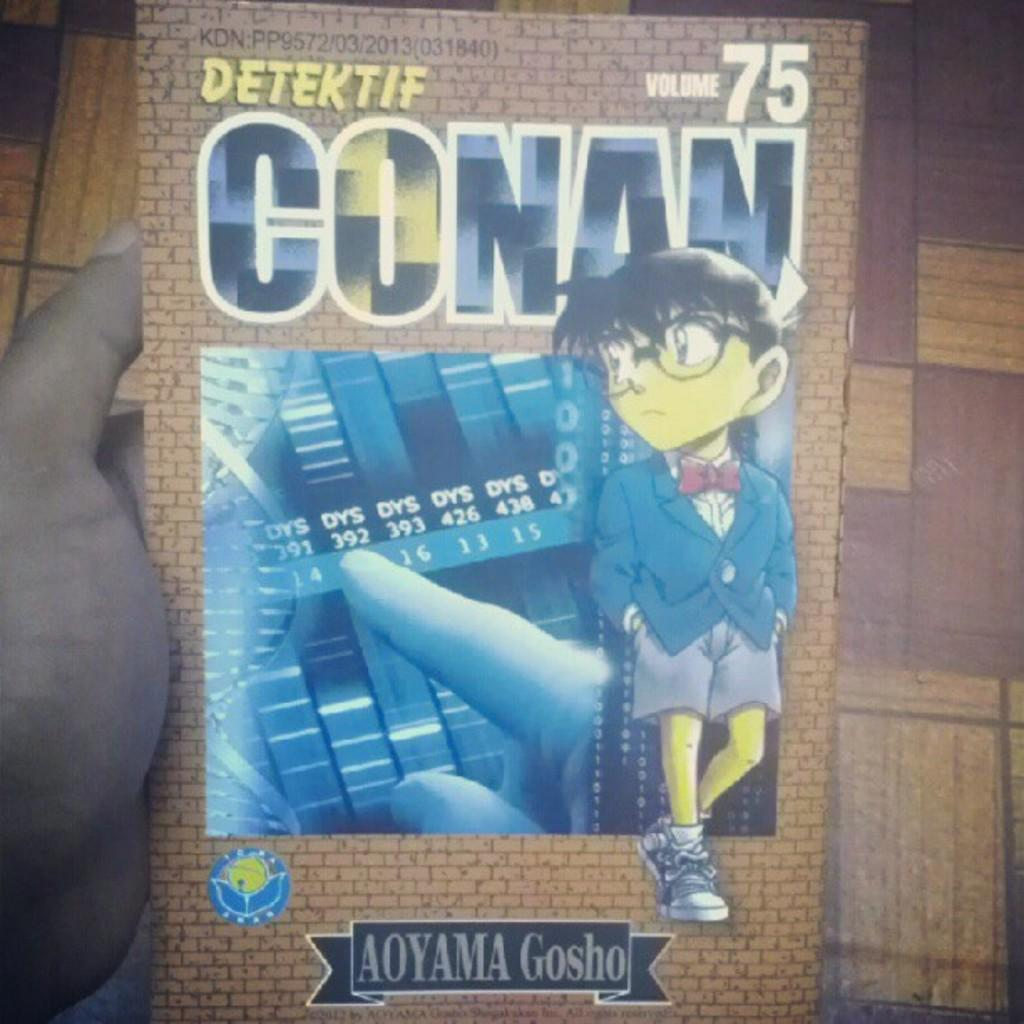<image>
Describe the image concisely. Volume 75 of the book "Detektif Conan" is held in someone's hand. 